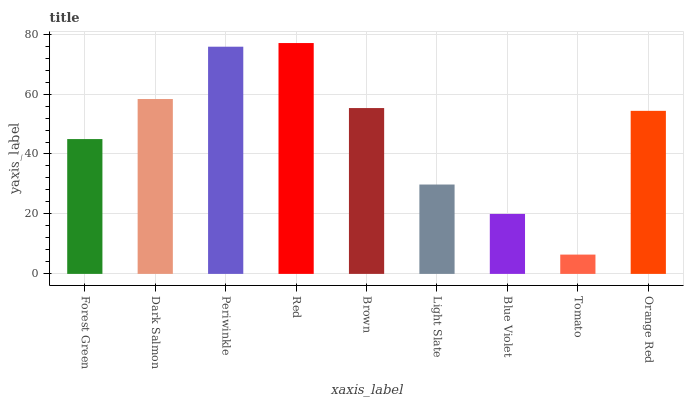Is Tomato the minimum?
Answer yes or no. Yes. Is Red the maximum?
Answer yes or no. Yes. Is Dark Salmon the minimum?
Answer yes or no. No. Is Dark Salmon the maximum?
Answer yes or no. No. Is Dark Salmon greater than Forest Green?
Answer yes or no. Yes. Is Forest Green less than Dark Salmon?
Answer yes or no. Yes. Is Forest Green greater than Dark Salmon?
Answer yes or no. No. Is Dark Salmon less than Forest Green?
Answer yes or no. No. Is Orange Red the high median?
Answer yes or no. Yes. Is Orange Red the low median?
Answer yes or no. Yes. Is Dark Salmon the high median?
Answer yes or no. No. Is Forest Green the low median?
Answer yes or no. No. 